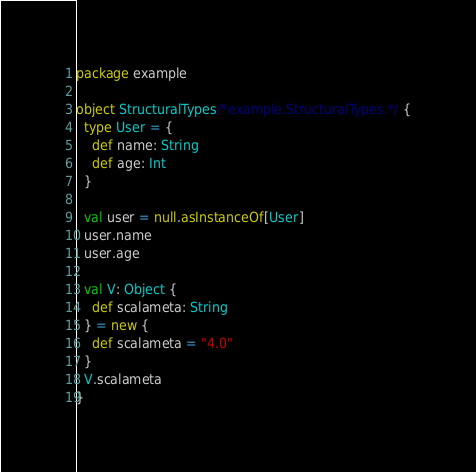<code> <loc_0><loc_0><loc_500><loc_500><_Scala_>package example

object StructuralTypes/*example.StructuralTypes.*/ {
  type User = {
    def name: String
    def age: Int
  }

  val user = null.asInstanceOf[User]
  user.name
  user.age

  val V: Object {
    def scalameta: String
  } = new {
    def scalameta = "4.0"
  }
  V.scalameta
}
</code> 